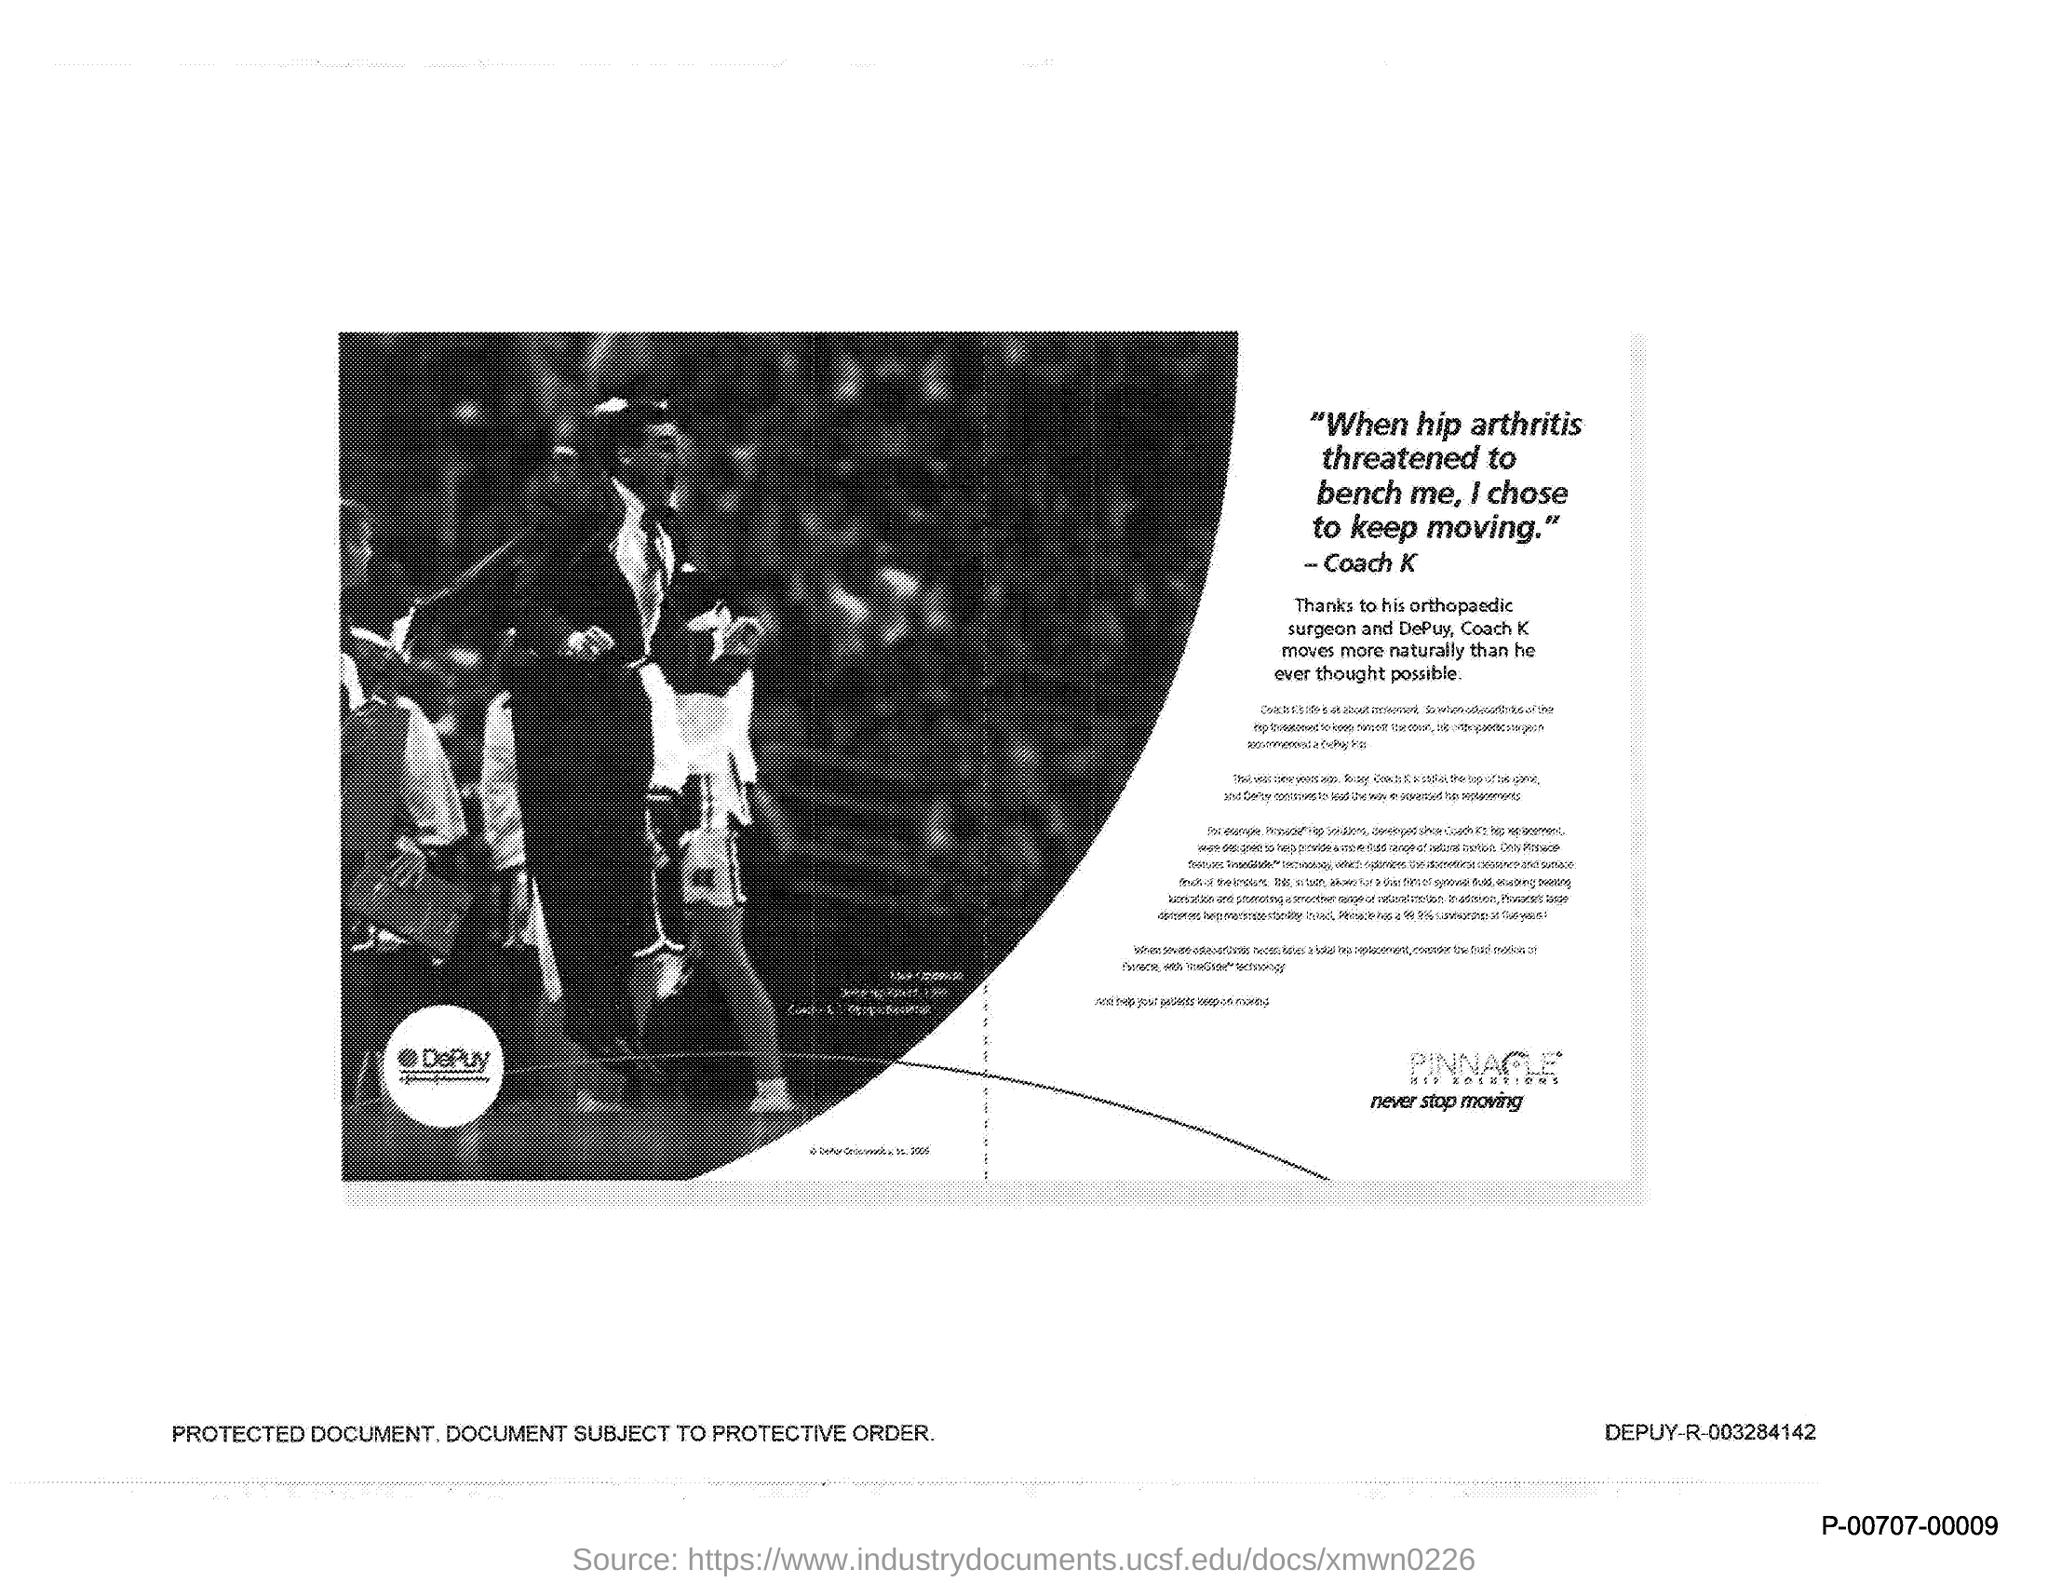Whom did Coach K thanked?
Give a very brief answer. Orthopaedic surgeon and depuy. Who moved very naturally than ever thought possible?
Offer a terse response. Coach K. What threatened Coach K?
Your answer should be very brief. Hip arthritis. 